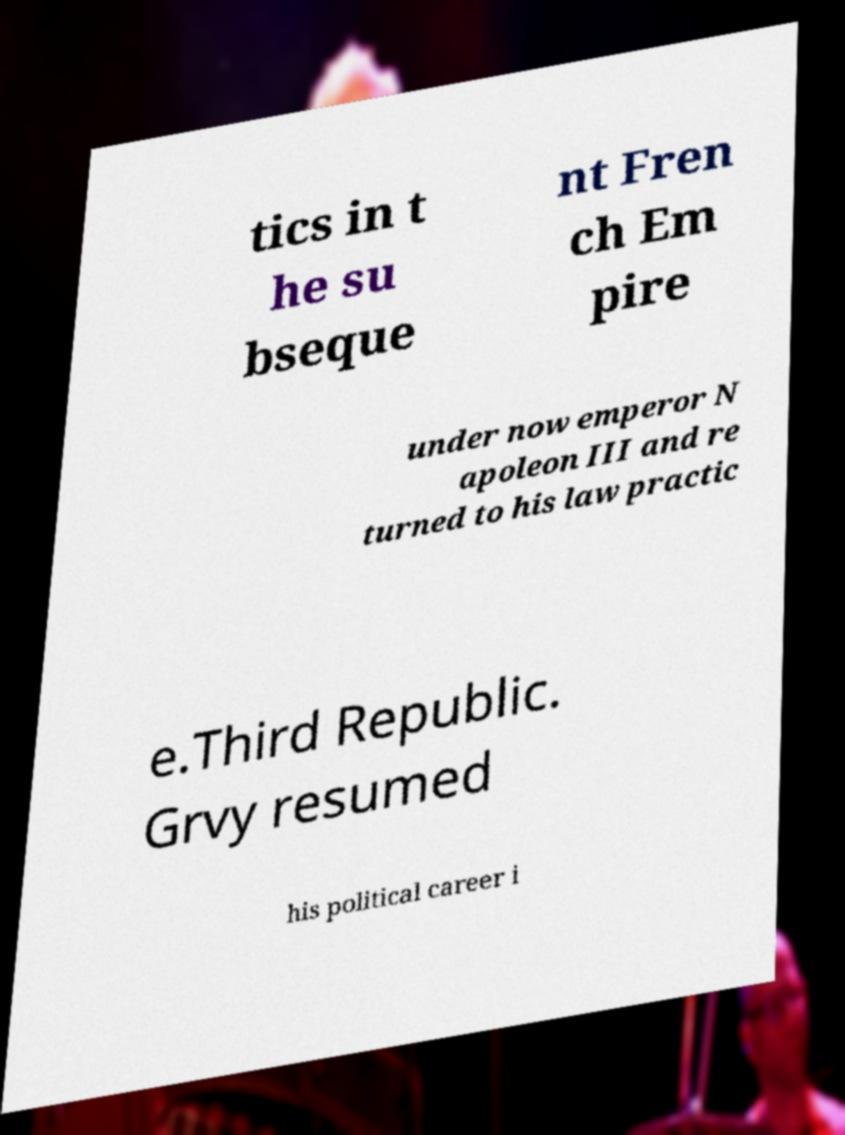Can you read and provide the text displayed in the image?This photo seems to have some interesting text. Can you extract and type it out for me? tics in t he su bseque nt Fren ch Em pire under now emperor N apoleon III and re turned to his law practic e.Third Republic. Grvy resumed his political career i 